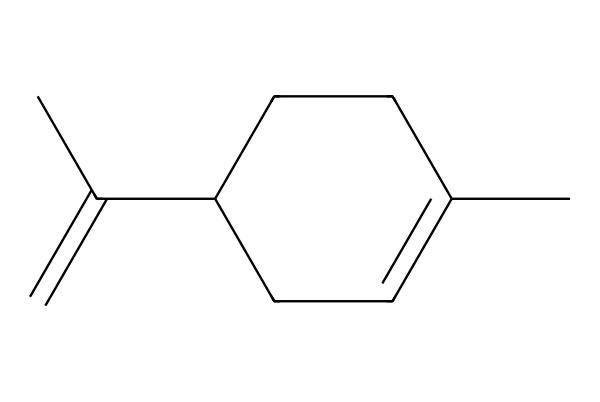What is the molecular formula of limonene? To determine the molecular formula, we count the number of carbon (C) and hydrogen (H) atoms in the structure. The SMILES notation shows that there are 10 carbons (C) and 16 hydrogens (H). Therefore, the molecular formula is C10H16.
Answer: C10H16 How many double bonds are present in limonene? In the given SMILES structure, we can identify the presence of a double bond in the ring structure of the cycloalkene and another one in the side chain. A total of two double bonds are present.
Answer: 2 What type of compound is limonene categorized as? Limonene is a monoterpene, which is a type of hydrocarbon derived from natural sources like citrus fruits. The overall structure includes a ring and multiple carbon atoms typical of terpenes.
Answer: monoterpene Is limonene considered polar or non-polar? The structure of limonene consists mostly of carbon and hydrogen, with a very low presence of electronegative elements such as oxygen. This makes limonene a non-polar compound.
Answer: non-polar What aroma characteristic does limonene impart in cleaning products? The arrangement of atoms and the specific functional groups in limonene contribute to a strong citrus scent that is commonly associated with lemon and orange, often utilized in cleaning products.
Answer: citrus scent In what natural products is limonene commonly found? Limonene is naturally occurring and can be commonly found in the peel oils of citrus fruits like lemons and oranges, as indicated by the molecular structure with its citrus-like properties.
Answer: citrus fruits 